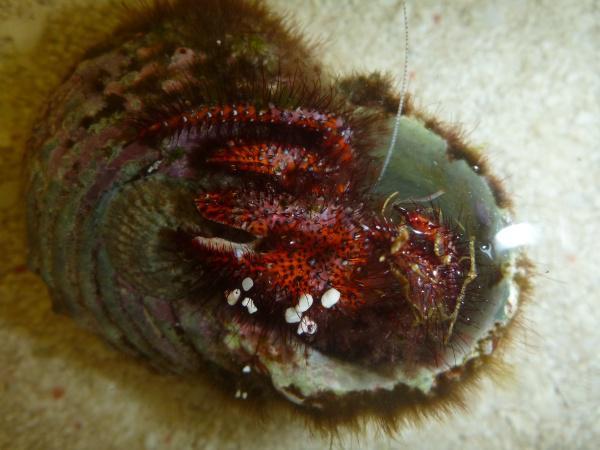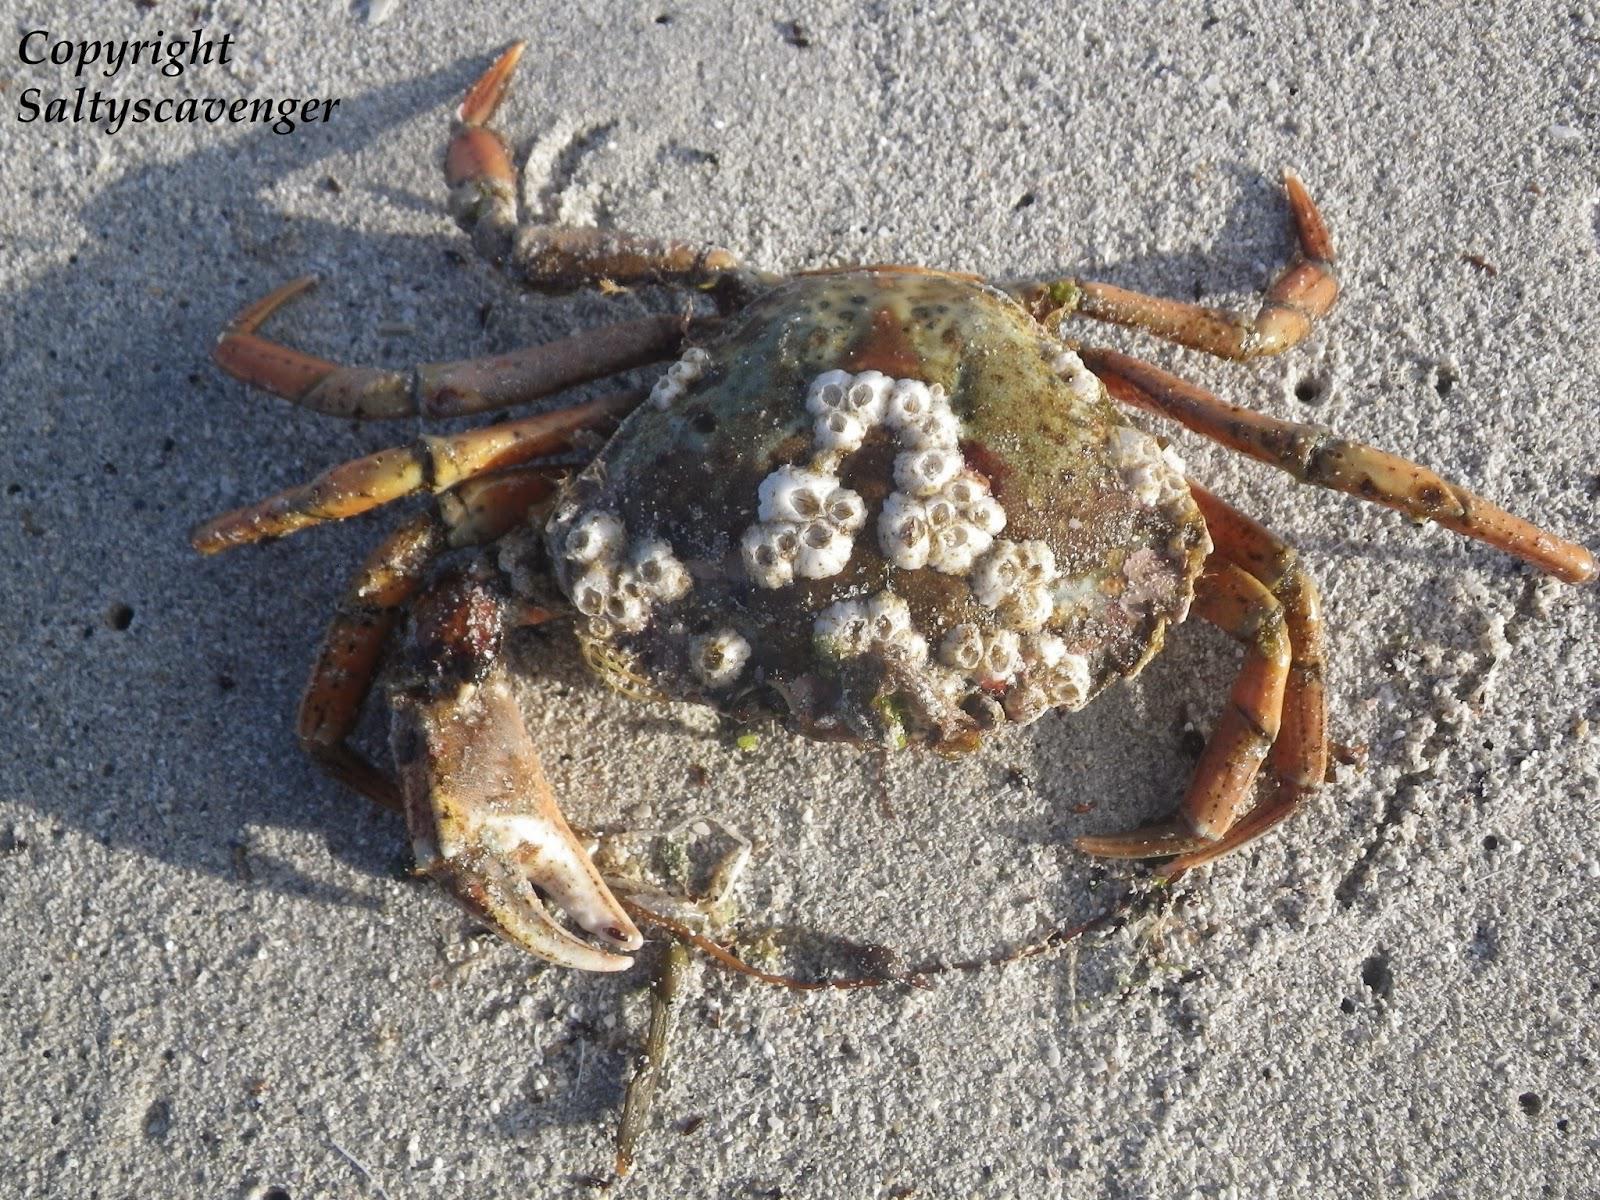The first image is the image on the left, the second image is the image on the right. Evaluate the accuracy of this statement regarding the images: "In at least one image there is a crab walking in the sand with at least 5 barnacles on top of the crab.". Is it true? Answer yes or no. Yes. The first image is the image on the left, the second image is the image on the right. Considering the images on both sides, is "The right image is a top-view of a crab on dry sand, with its shell face-up and dotted with barnacles." valid? Answer yes or no. Yes. 